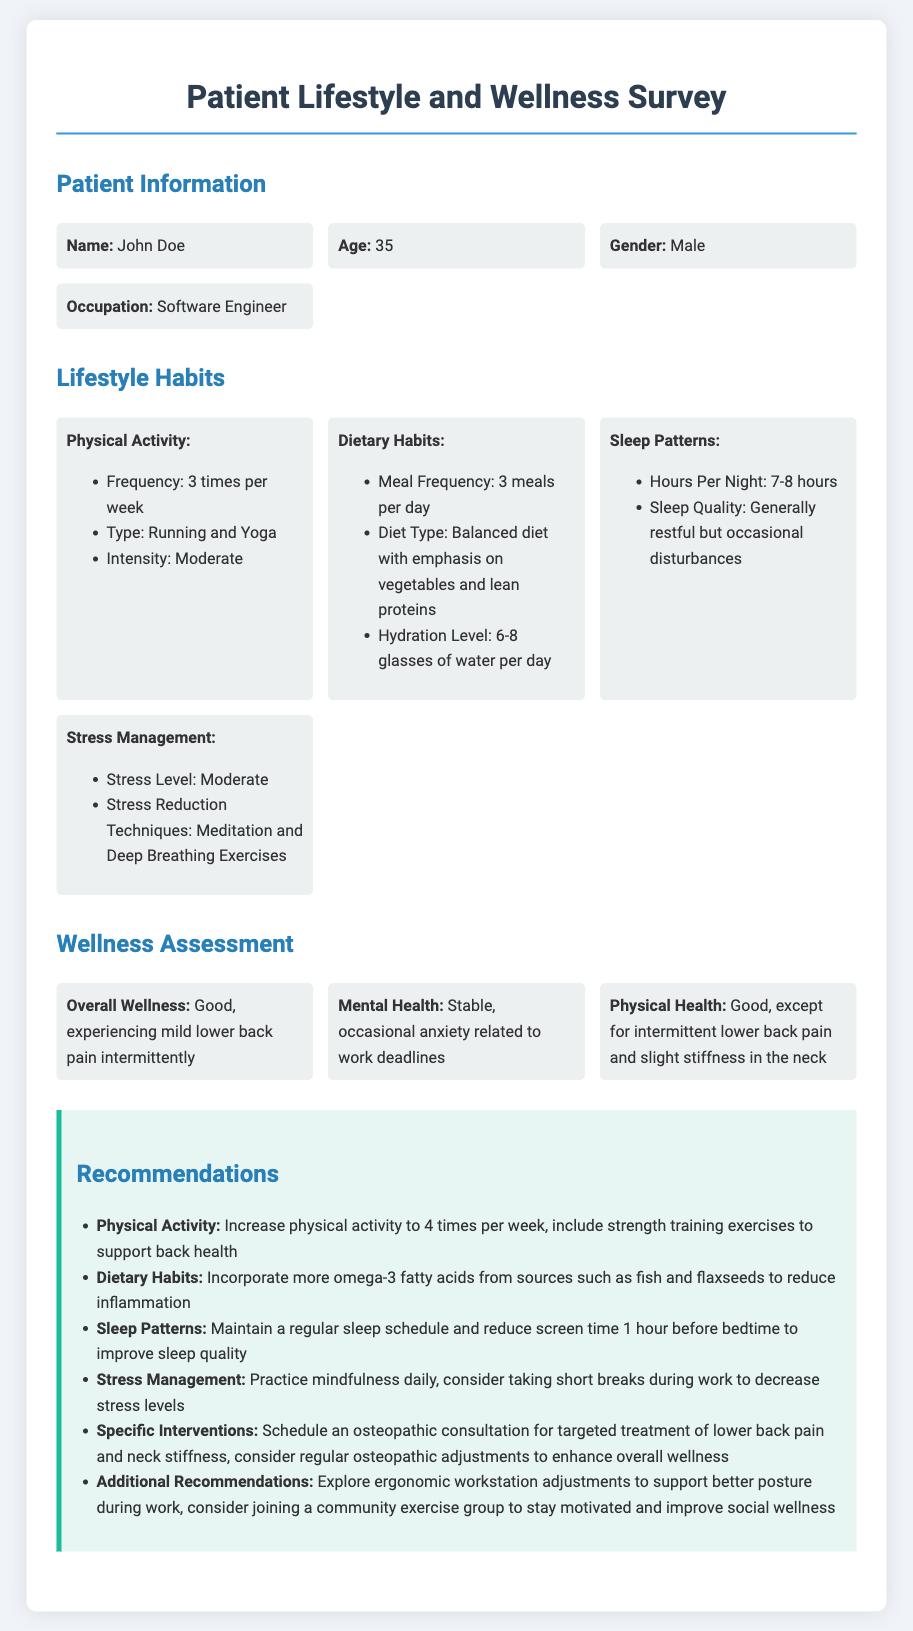what is the patient's name? The patient's name is provided in the document under the "Patient Information" section.
Answer: John Doe how many hours of sleep does the patient get per night? The hours of sleep are noted in the "Sleep Patterns" section, which states the typical range of hours.
Answer: 7-8 hours what is the patient's stress level? The stress level is indicated in the "Stress Management" section.
Answer: Moderate which activities does the patient engage in for physical activity? The types of physical activities are mentioned in the "Lifestyle Habits" section.
Answer: Running and Yoga what dietary habits does the patient follow? The dietary habits are outlined in the "Dietary Habits" subsection of the "Lifestyle Habits" section.
Answer: Balanced diet with emphasis on vegetables and lean proteins what is the recommendation for physical activity frequency? The recommended frequency for physical activity is specified in the "Recommendations" section.
Answer: 4 times per week what issues does the patient experience regarding their mental health? The document mentions the patient's mental health situation in the "Wellness Assessment" section.
Answer: Occasional anxiety related to work deadlines what specific interventions are recommended for the patient's back pain? The document lists specific interventions in the "Recommendations" section for addressing lower back pain.
Answer: Schedule an osteopathic consultation what improvements are suggested for the patient's sleep quality? The recommendations for sleep quality are mentioned in the "Recommendations" section.
Answer: Reduce screen time 1 hour before bedtime 